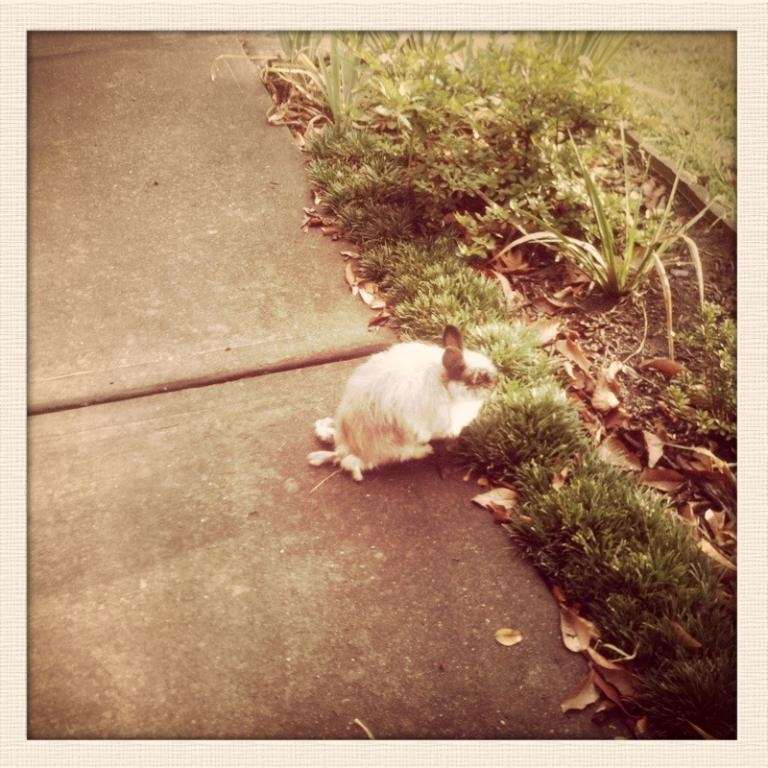What type of animal is on the surface in the image? There is a mammal on the surface in the image. What other living organisms can be seen in the image? There are plants in the image. What type of vegetation is present on the ground in the image? There is grass on the ground in the image. What else can be found on the ground in the image? There are leaves on the ground in the image. What month is depicted in the image? The image does not depict a specific month; it only shows a mammal, plants, grass, leaves, and a blurred background. 